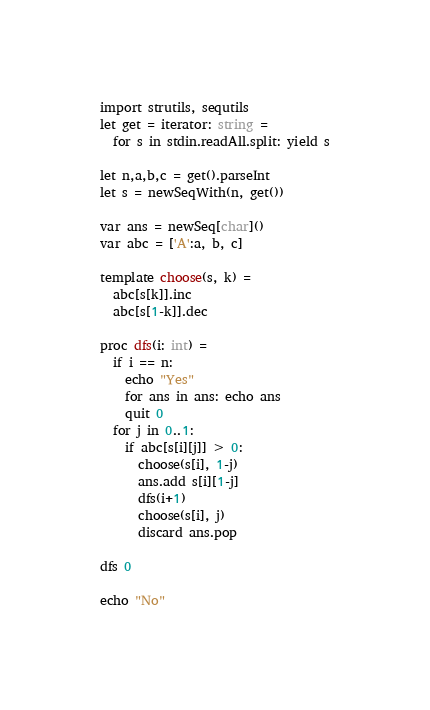<code> <loc_0><loc_0><loc_500><loc_500><_Nim_>import strutils, sequtils
let get = iterator: string =
  for s in stdin.readAll.split: yield s

let n,a,b,c = get().parseInt
let s = newSeqWith(n, get())

var ans = newSeq[char]()
var abc = ['A':a, b, c]

template choose(s, k) =
  abc[s[k]].inc
  abc[s[1-k]].dec

proc dfs(i: int) =
  if i == n:
    echo "Yes"
    for ans in ans: echo ans
    quit 0
  for j in 0..1:
    if abc[s[i][j]] > 0:
      choose(s[i], 1-j)
      ans.add s[i][1-j]
      dfs(i+1)
      choose(s[i], j)
      discard ans.pop

dfs 0

echo "No"</code> 